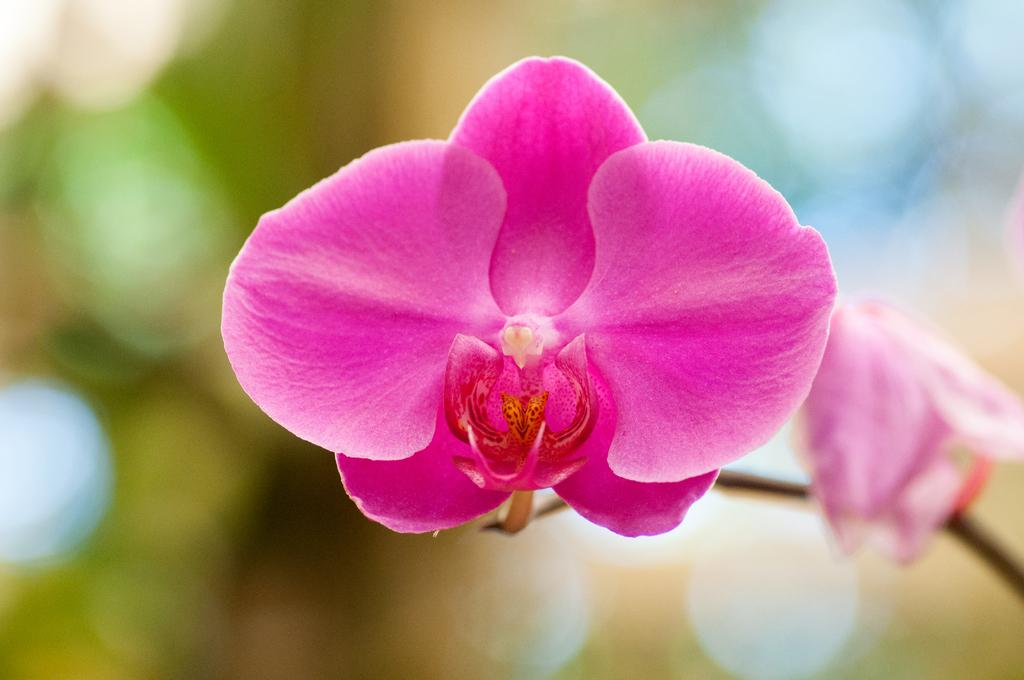What is the main subject of the image? There is a flower in the image. Can you describe the color of the flower? The flower is pink in color. How would you describe the background of the image? The background of the image is blurred. Where is the hose located in the image? There is no hose present in the image. What type of animal can be seen interacting with the flower in the image? There is no animal present in the image; it only features a pink flower with a blurred background. 